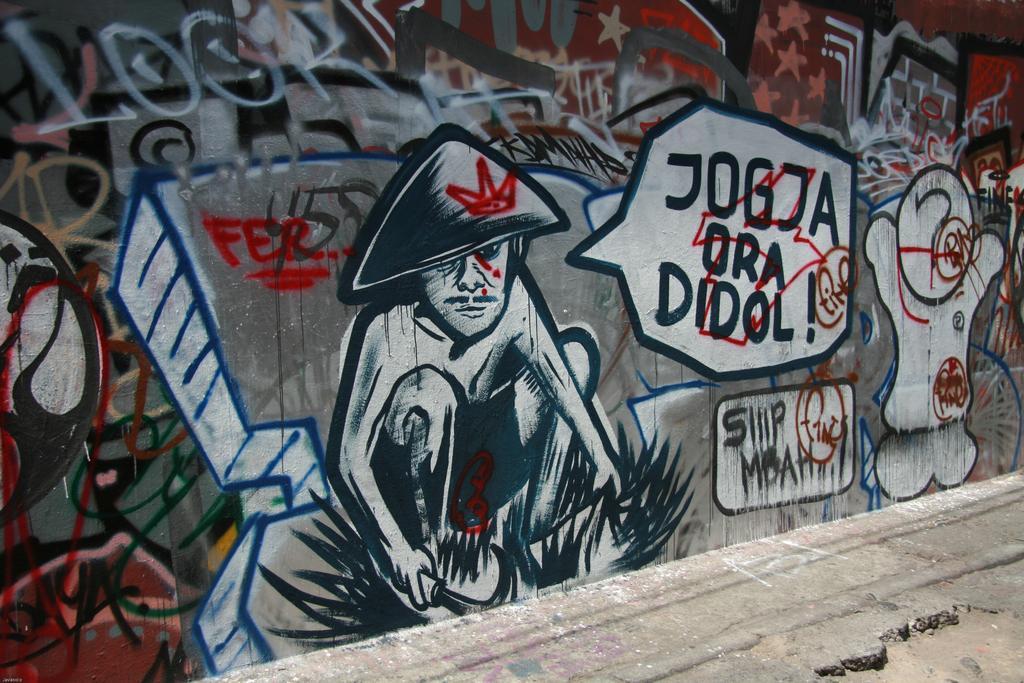In one or two sentences, can you explain what this image depicts? Here I can see a wall on which I can see some paintings and text. At the bottom I can see the road. 